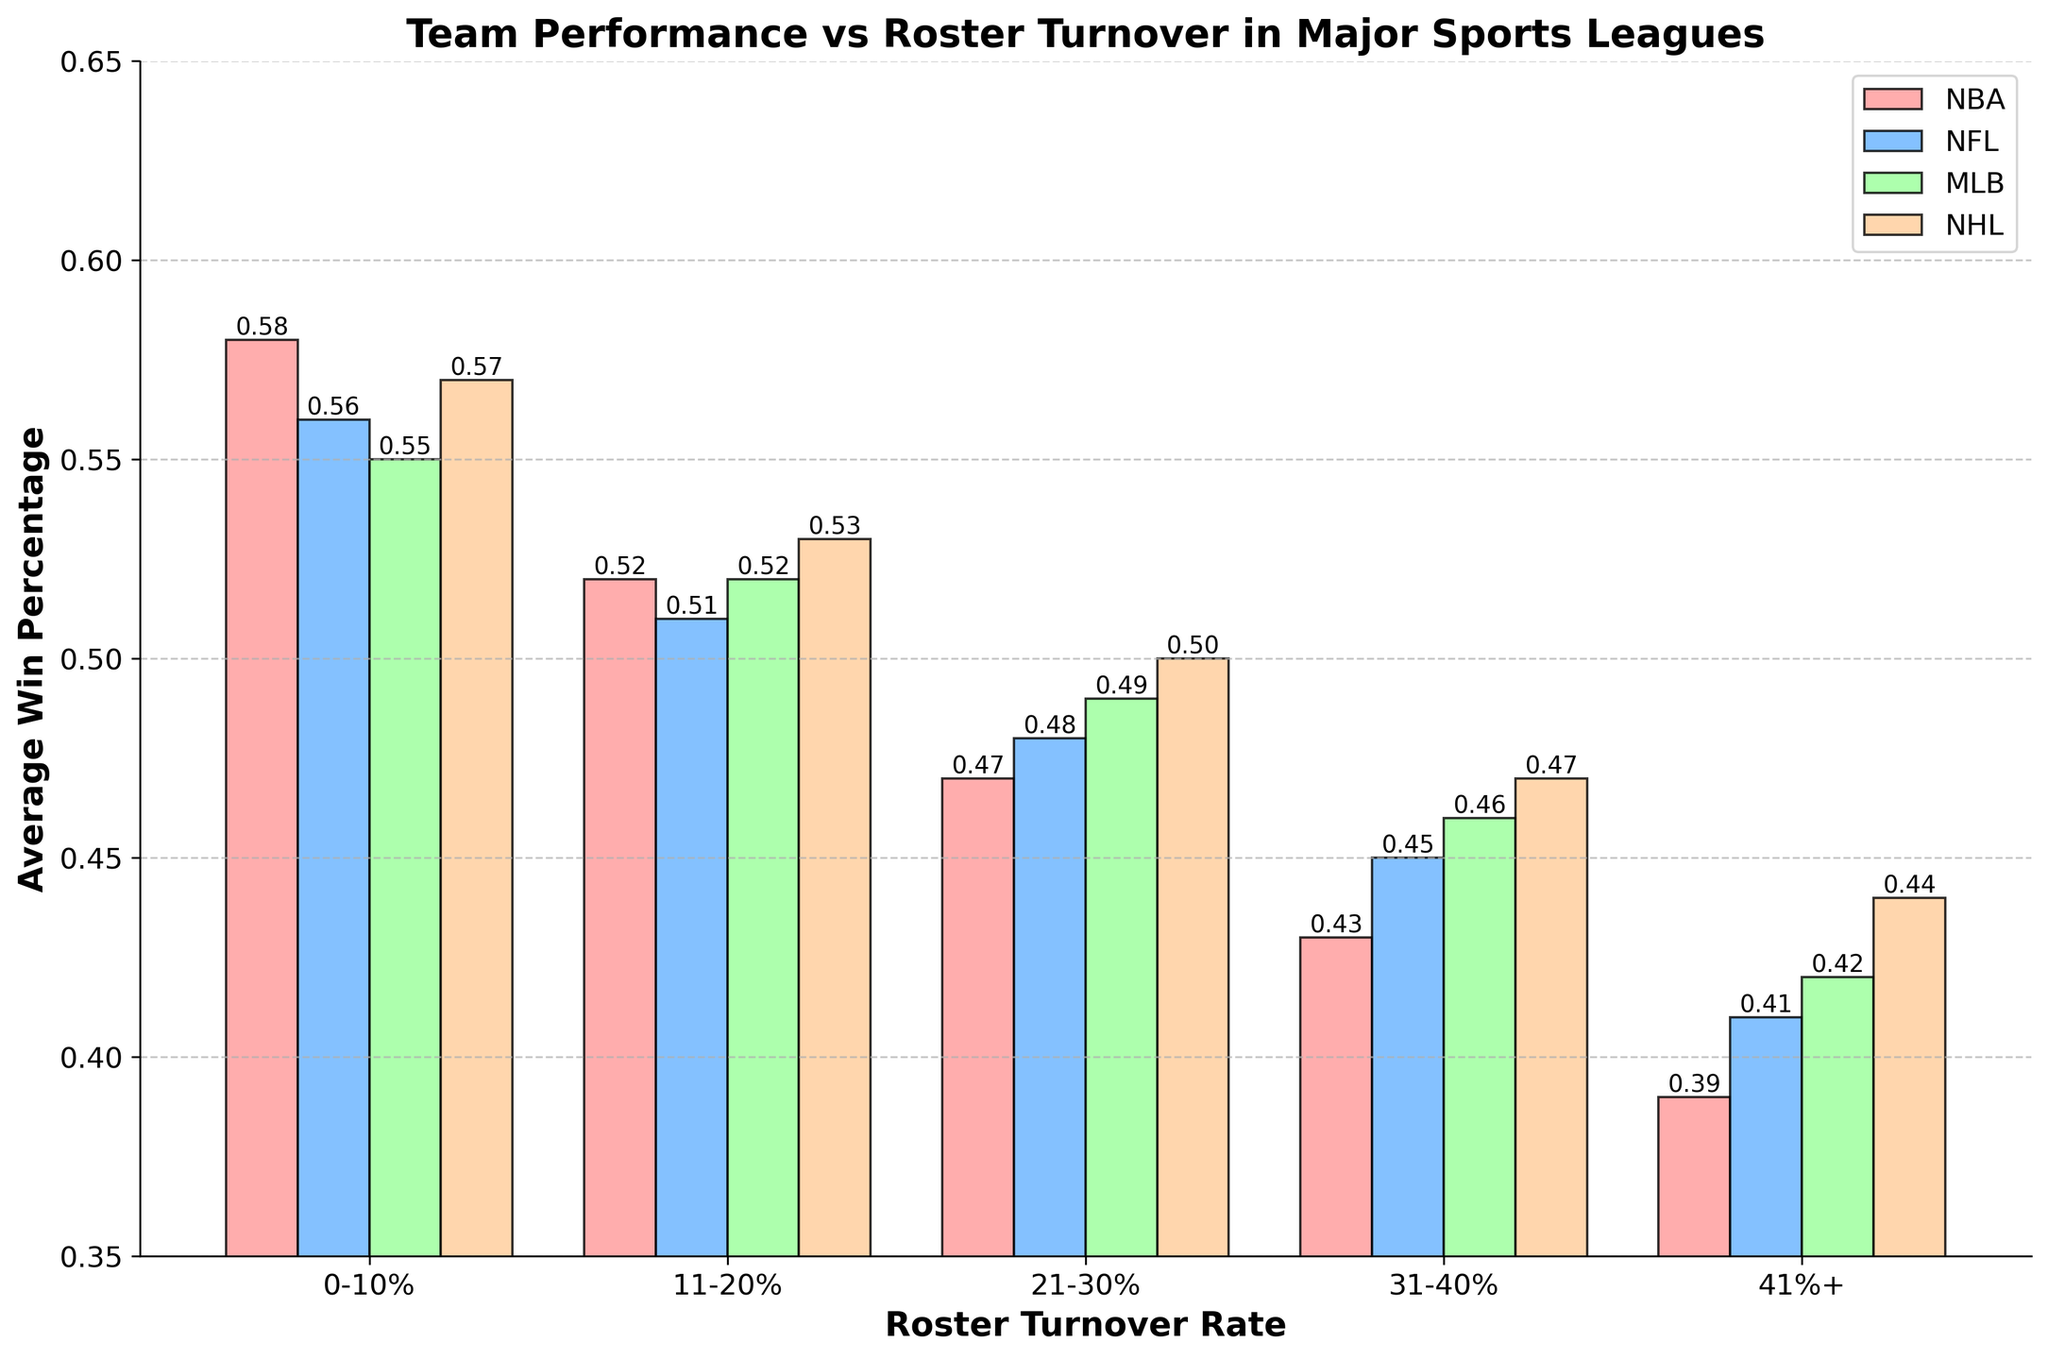Which league has the lowest average win percentage when roster turnover is 41%+? To find the answer, look at the bar for the 41%+ turnover rate across the different leagues and identify which one has the shortest height, indicating the lowest win percentage. In the figure, the NFL has the lowest bar at 41%+.
Answer: NFL How does the average win percentage change for the NBA when turnover increases from 0-10% to 41%+? The average win percentage for the NBA with a 0-10% turnover rate is 0.58, and it decreases to 0.39 when the turnover rate is 41%+. The change is 0.58 - 0.39 = 0.19.
Answer: It decreases by 0.19 Which league shows the smallest drop in win percentage from a 0-10% turnover rate to a 41%+ turnover rate? Calculate the difference in win percentages between the 0-10% turnover rate and the 41%+ turnover rate for each league, and identify the smallest value. For the NBA, it is 0.58 - 0.39 = 0.19. For the NFL, it is 0.56 - 0.41 = 0.15. For the MLB, it is 0.55 - 0.42 = 0.13. For the NHL, it is 0.57 - 0.44 = 0.13. The MLB and NHL both have the smallest drop of 0.13.
Answer: MLB and NHL Are the win percentages for all leagues higher when roster turnover is between 0-10% compared to 41%+? Compare the average win percentages for each league between turnover rates of 0-10% and 41%+. For the NBA, it is 0.58 vs. 0.39. For the NFL, it is 0.56 vs. 0.41. For the MLB, it is 0.55 vs. 0.42. For the NHL, it is 0.57 vs. 0.44. In all cases, the win percentage for the 0-10% turnover rate is higher.
Answer: Yes Which turnover rate interval shows the steepest decline in win percentage for the NFL? Examine the win percentages for the NFL across the different turnover rate intervals. The differences are: 0.56 (0-10%) to 0.51 (11-20%) = 0.05, 0.51 (11-20%) to 0.48 (21-30%) = 0.03, 0.48 (21-30%) to 0.45 (31-40%) = 0.03, and 0.45 (31-40%) to 0.41 (41%+) = 0.04.
Answer: 0-10% to 11-20% What is the average win percentage for the NHL when combining the 0-10% and 11-20% turnover rates? First, find the individual win percentages for these intervals: 0.57 (0-10%) and 0.53 (11-20%). Then, calculate the average: (0.57 + 0.53) / 2 = 0.55.
Answer: 0.55 Which leagues have a win percentage above 0.50 with a 21-30% turnover rate? Examine the bars corresponding to a 21-30% turnover rate and identify which bars are above the 0.50 mark. The leagues are NBA with 0.47, NFL with 0.48, MLB with 0.49, and NHL with 0.50. Only the NHL is above 0.50.
Answer: NHL Is the decline in win percentage for the NHL more significant between the 0-10% and 21-30% intervals or the 21-30% and 41%+ intervals? Calculate the differences for the NHL: 0.57 (0-10%) to 0.50 (21-30%) = 0.07, and 0.50 (21-30%) to 0.44 (41%+) = 0.06. The 0-10% to 21-30% interval shows a more significant decline of 0.07.
Answer: Between 0-10% and 21-30% Which league maintains the highest win percentage in the 31-40% turnover rate interval? Examine the bars corresponding to the 31-40% turnover rate to identify the tallest one. For the 31-40% turnover rate, the NBA has 0.43, NFL has 0.45, MLB has 0.46, and NHL has 0.47. The NHL has the highest win percentage.
Answer: NHL 